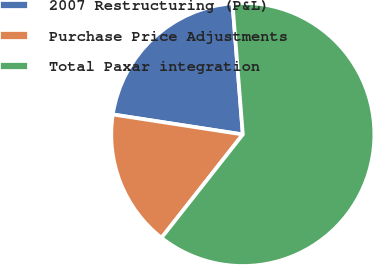Convert chart to OTSL. <chart><loc_0><loc_0><loc_500><loc_500><pie_chart><fcel>2007 Restructuring (P&L)<fcel>Purchase Price Adjustments<fcel>Total Paxar integration<nl><fcel>21.32%<fcel>16.82%<fcel>61.86%<nl></chart> 